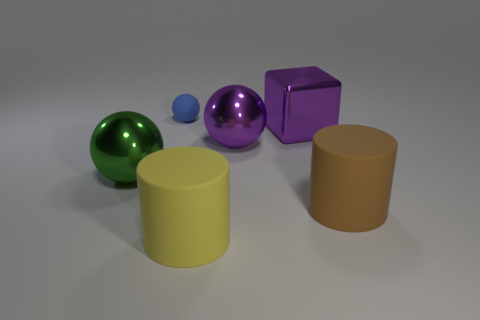Are the purple ball right of the green object and the thing that is on the left side of the small ball made of the same material?
Give a very brief answer. Yes. There is a purple metal thing that is left of the purple metal cube; what is its shape?
Keep it short and to the point. Sphere. The purple object that is the same shape as the blue rubber object is what size?
Give a very brief answer. Large. Does the rubber ball have the same color as the shiny cube?
Keep it short and to the point. No. Is there anything else that is the same shape as the green metallic thing?
Ensure brevity in your answer.  Yes. Is there a large cylinder that is on the left side of the large sphere on the right side of the matte sphere?
Make the answer very short. Yes. There is another large rubber object that is the same shape as the big yellow rubber thing; what is its color?
Give a very brief answer. Brown. What number of cylinders have the same color as the tiny rubber thing?
Provide a succinct answer. 0. The sphere to the right of the blue ball on the left side of the matte cylinder that is to the left of the large purple sphere is what color?
Offer a terse response. Purple. Do the small blue object and the purple cube have the same material?
Your answer should be very brief. No. 